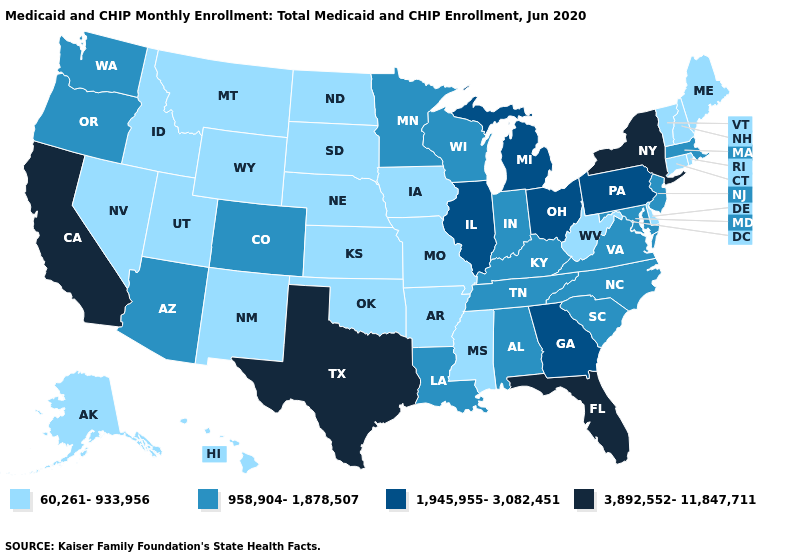Is the legend a continuous bar?
Short answer required. No. Does Mississippi have the lowest value in the USA?
Short answer required. Yes. What is the value of Idaho?
Short answer required. 60,261-933,956. Among the states that border Massachusetts , which have the highest value?
Keep it brief. New York. Name the states that have a value in the range 1,945,955-3,082,451?
Write a very short answer. Georgia, Illinois, Michigan, Ohio, Pennsylvania. Name the states that have a value in the range 3,892,552-11,847,711?
Be succinct. California, Florida, New York, Texas. Name the states that have a value in the range 958,904-1,878,507?
Concise answer only. Alabama, Arizona, Colorado, Indiana, Kentucky, Louisiana, Maryland, Massachusetts, Minnesota, New Jersey, North Carolina, Oregon, South Carolina, Tennessee, Virginia, Washington, Wisconsin. What is the lowest value in the USA?
Give a very brief answer. 60,261-933,956. Does the map have missing data?
Concise answer only. No. Which states have the lowest value in the West?
Be succinct. Alaska, Hawaii, Idaho, Montana, Nevada, New Mexico, Utah, Wyoming. Does North Carolina have the lowest value in the South?
Concise answer only. No. Does Georgia have the same value as Wyoming?
Short answer required. No. What is the value of Georgia?
Keep it brief. 1,945,955-3,082,451. Does Montana have the lowest value in the USA?
Concise answer only. Yes. Which states hav the highest value in the West?
Give a very brief answer. California. 